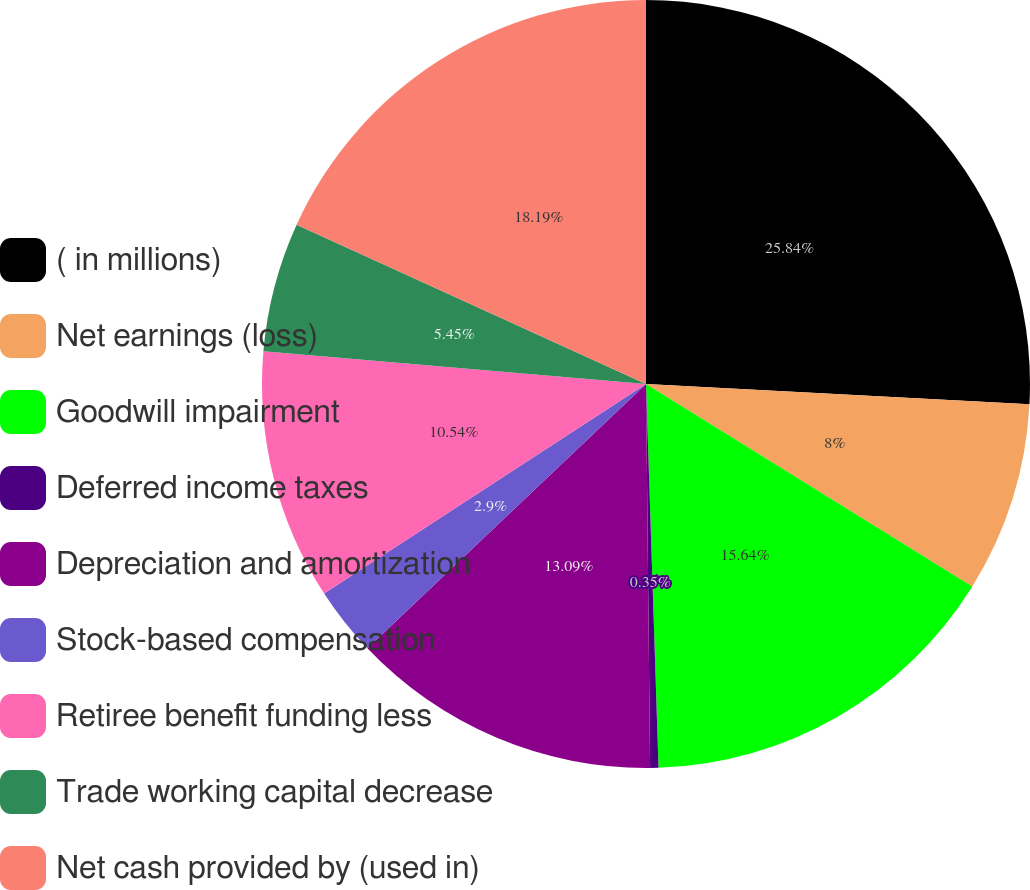<chart> <loc_0><loc_0><loc_500><loc_500><pie_chart><fcel>( in millions)<fcel>Net earnings (loss)<fcel>Goodwill impairment<fcel>Deferred income taxes<fcel>Depreciation and amortization<fcel>Stock-based compensation<fcel>Retiree benefit funding less<fcel>Trade working capital decrease<fcel>Net cash provided by (used in)<nl><fcel>25.84%<fcel>8.0%<fcel>15.64%<fcel>0.35%<fcel>13.09%<fcel>2.9%<fcel>10.54%<fcel>5.45%<fcel>18.19%<nl></chart> 